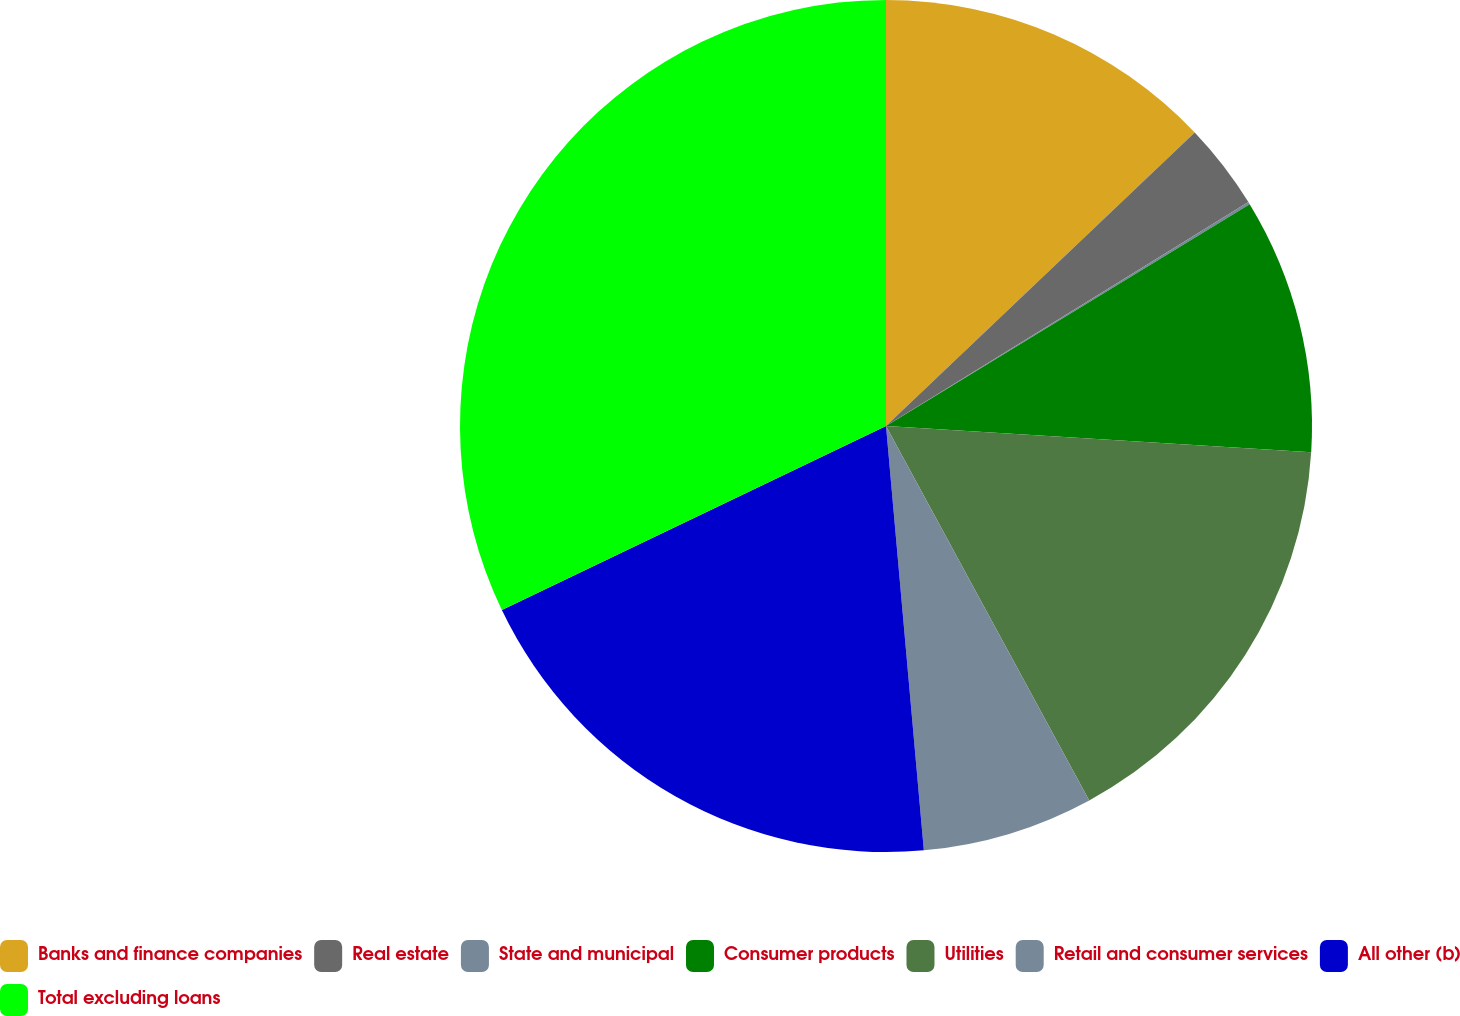Convert chart. <chart><loc_0><loc_0><loc_500><loc_500><pie_chart><fcel>Banks and finance companies<fcel>Real estate<fcel>State and municipal<fcel>Consumer products<fcel>Utilities<fcel>Retail and consumer services<fcel>All other (b)<fcel>Total excluding loans<nl><fcel>12.9%<fcel>3.29%<fcel>0.09%<fcel>9.7%<fcel>16.1%<fcel>6.5%<fcel>19.3%<fcel>32.11%<nl></chart> 